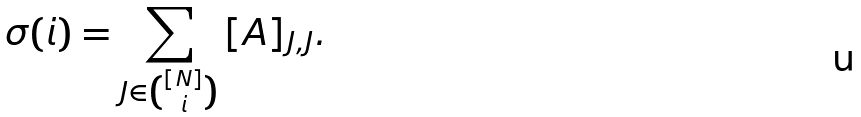Convert formula to latex. <formula><loc_0><loc_0><loc_500><loc_500>\sigma ( i ) = \sum _ { J \in \binom { [ N ] } { i } } { [ A ] _ { J , J } } .</formula> 